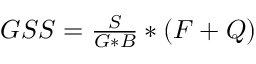<formula> <loc_0><loc_0><loc_500><loc_500>\begin{array} { r } { G S S = \frac { S } G * B } * ( F + Q ) } \end{array}</formula> 